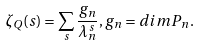Convert formula to latex. <formula><loc_0><loc_0><loc_500><loc_500>\zeta _ { Q } ( s ) = \sum _ { s } \frac { g _ { n } } { \lambda _ { n } ^ { s } } , g _ { n } = d i m P _ { n } .</formula> 